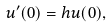Convert formula to latex. <formula><loc_0><loc_0><loc_500><loc_500>u ^ { \prime } ( 0 ) = h u ( 0 ) ,</formula> 